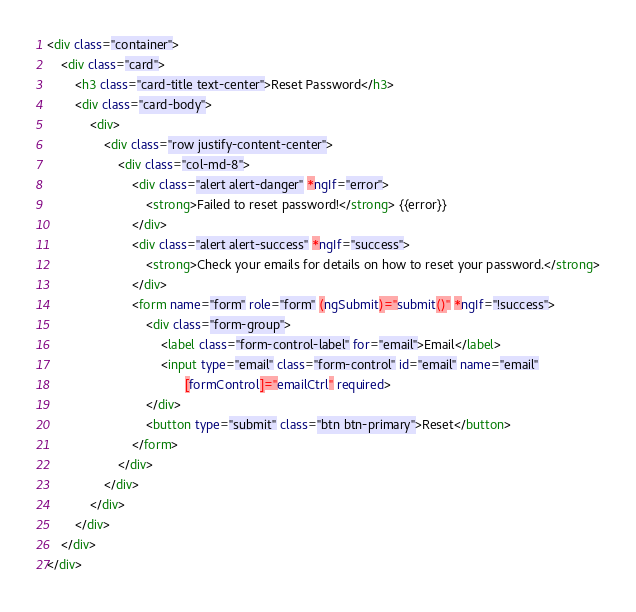<code> <loc_0><loc_0><loc_500><loc_500><_HTML_><div class="container">
    <div class="card">
        <h3 class="card-title text-center">Reset Password</h3>
        <div class="card-body">
            <div>
                <div class="row justify-content-center">
                    <div class="col-md-8">
                        <div class="alert alert-danger" *ngIf="error">
                            <strong>Failed to reset password!</strong> {{error}}
                        </div>
                        <div class="alert alert-success" *ngIf="success">
                            <strong>Check your emails for details on how to reset your password.</strong>
                        </div>
                        <form name="form" role="form" (ngSubmit)="submit()" *ngIf="!success">
                            <div class="form-group">
                                <label class="form-control-label" for="email">Email</label>
                                <input type="email" class="form-control" id="email" name="email"
                                       [formControl]="emailCtrl" required>
                            </div>
                            <button type="submit" class="btn btn-primary">Reset</button>
                        </form>
                    </div>
                </div>
            </div>
        </div>
    </div>
</div>
</code> 